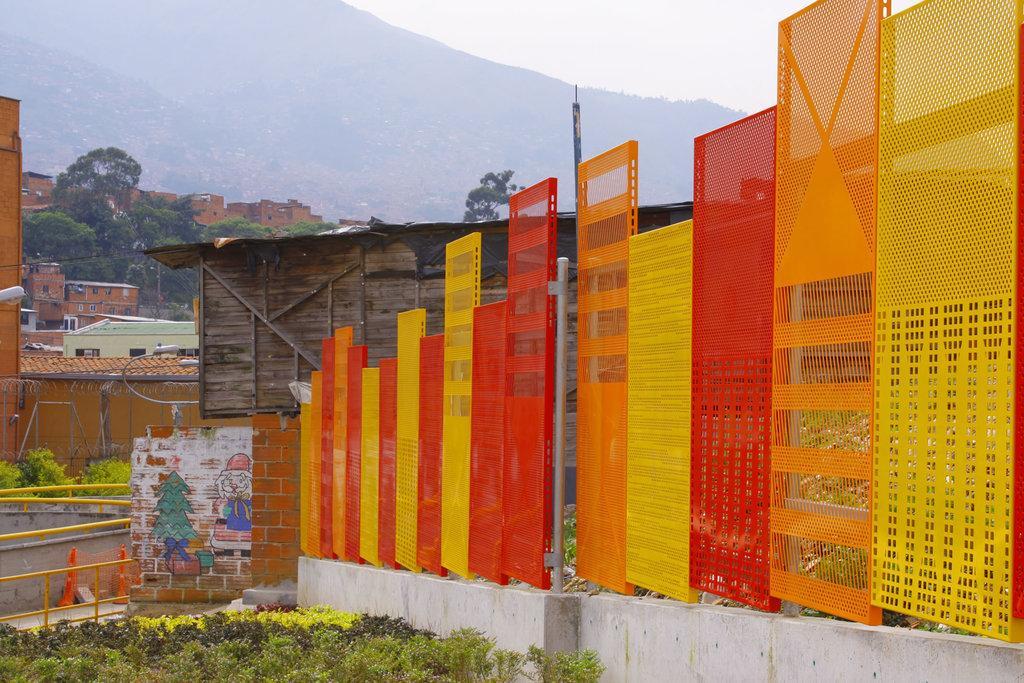In one or two sentences, can you explain what this image depicts? In this picture we can see there are plants and on the right side of the plants there is a wall with some colorful objects and a pole. Behind the plants there are buildings, trees, hills and a sky. 